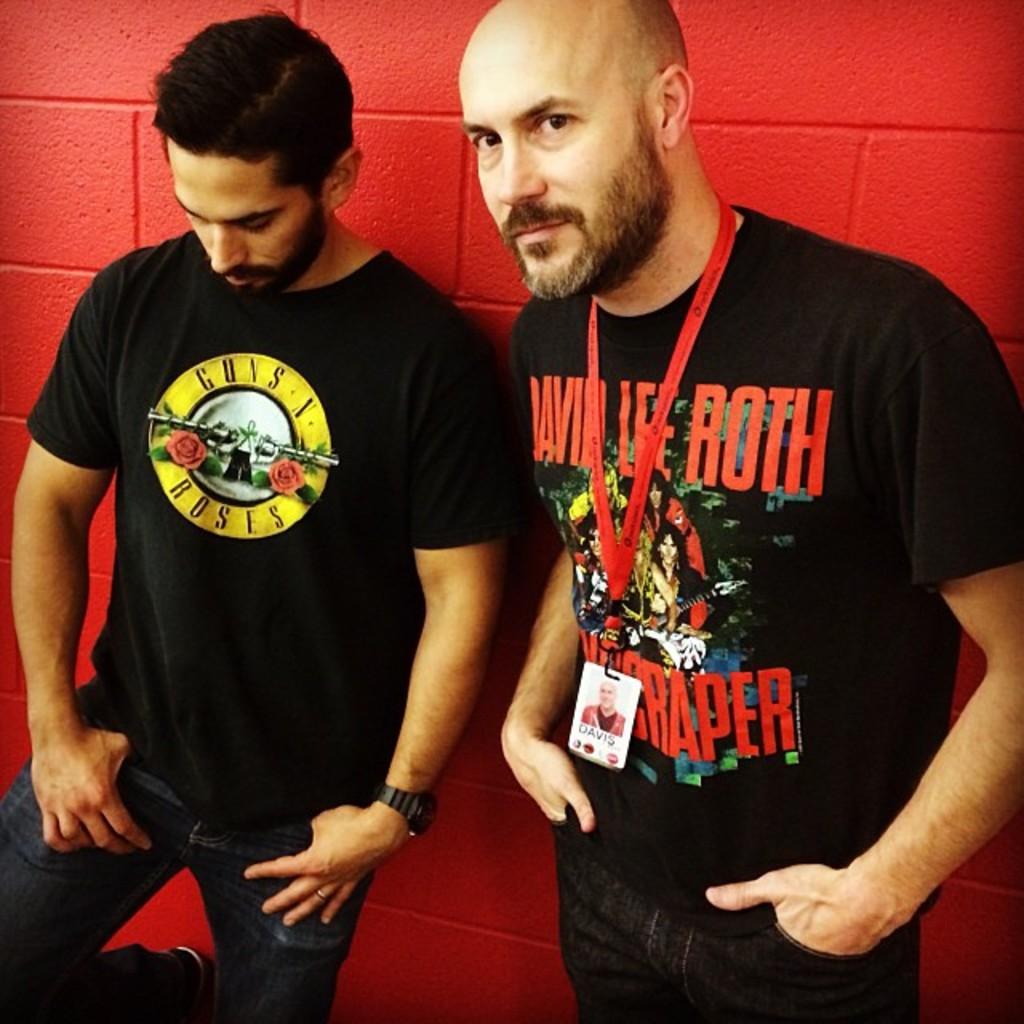What band t-shirt is the man on the left wearing?
Ensure brevity in your answer.  Guns n roses. Which artist is on person on the right's tshirt?
Give a very brief answer. David lee roth. 